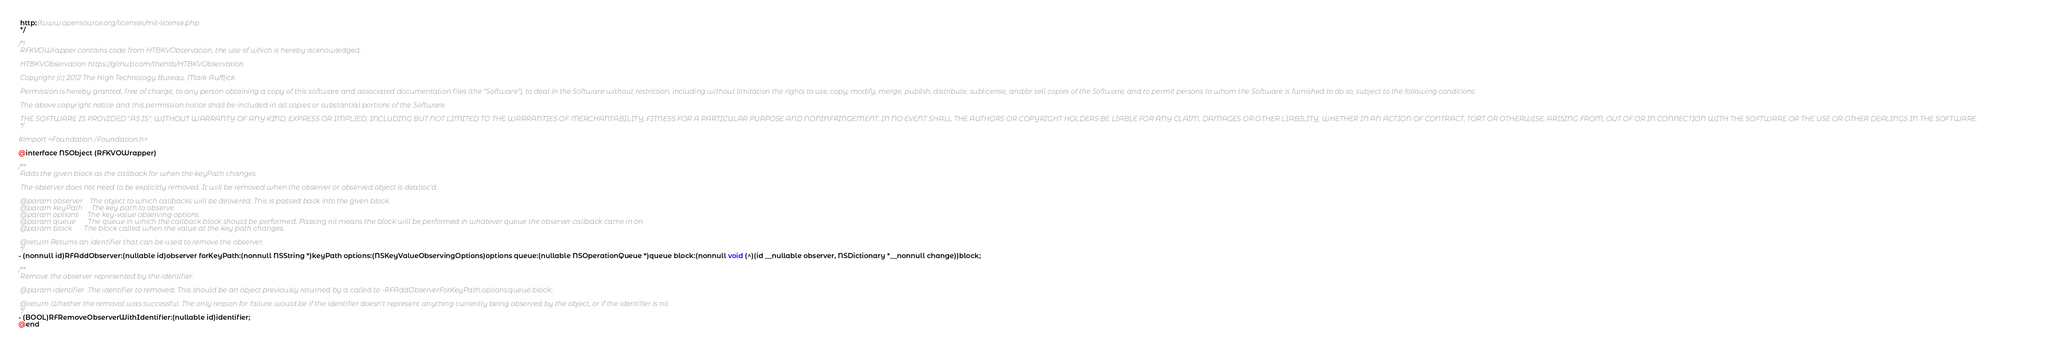Convert code to text. <code><loc_0><loc_0><loc_500><loc_500><_C_> http://www.opensource.org/licenses/mit-license.php
 */

/*!
 RFKVOWrapper contains code from HTBKVObservation, the use of which is hereby acknowledged.

 HTBKVObservation https://github.com/thehtb/HTBKVObservation

 Copyright (c) 2012 The High Technology Bureau, Mark Aufflick

 Permission is hereby granted, free of charge, to any person obtaining a copy of this software and associated documentation files (the "Software"), to deal in the Software without restriction, including without limitation the rights to use, copy, modify, merge, publish, distribute, sublicense, and/or sell copies of the Software, and to permit persons to whom the Software is furnished to do so, subject to the following conditions:

 The above copyright notice and this permission notice shall be included in all copies or substantial portions of the Software.

 THE SOFTWARE IS PROVIDED "AS IS", WITHOUT WARRANTY OF ANY KIND, EXPRESS OR IMPLIED, INCLUDING BUT NOT LIMITED TO THE WARRANTIES OF MERCHANTABILITY, FITNESS FOR A PARTICULAR PURPOSE AND NONINFRINGEMENT. IN NO EVENT SHALL THE AUTHORS OR COPYRIGHT HOLDERS BE LIABLE FOR ANY CLAIM, DAMAGES OR OTHER LIABILITY, WHETHER IN AN ACTION OF CONTRACT, TORT OR OTHERWISE, ARISING FROM, OUT OF OR IN CONNECTION WITH THE SOFTWARE OR THE USE OR OTHER DEALINGS IN THE SOFTWARE.
 */

#import <Foundation/Foundation.h>

@interface NSObject (RFKVOWrapper)

/**
 Adds the given block as the callback for when the keyPath changes. 
 
 The observer does not need to be explicitly removed. It will be removed when the observer or observed object is dealloc'd.
 
 @param observer    The object to which callbacks will be delivered. This is passed back into the given block.
 @param keyPath     The key path to observe.
 @param options     The key-value observing options.
 @param queue       The queue in which the callback block should be performed. Passing nil means the block will be performed in whatever queue the observer callback came in on.
 @param block       The block called when the value at the key path changes.

 @return Returns an identifier that can be used to remove the observer.
 */
- (nonnull id)RFAddObserver:(nullable id)observer forKeyPath:(nonnull NSString *)keyPath options:(NSKeyValueObservingOptions)options queue:(nullable NSOperationQueue *)queue block:(nonnull void (^)(id __nullable observer, NSDictionary *__nonnull change))block;

/**
 Remove the observer represented by the identifier.
 
 @param identifier  The identifier to removed. This should be an object previously returned by a called to -RFAddObserverForKeyPath:options:queue:block:.
 
 @return Whether the removal was successful. The only reason for failure would be if the identifier doesn't represent anything currently being observed by the object, or if the identifier is nil.
 */
- (BOOL)RFRemoveObserverWithIdentifier:(nullable id)identifier;
@end
</code> 